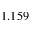<formula> <loc_0><loc_0><loc_500><loc_500>1 . 1 5 9</formula> 